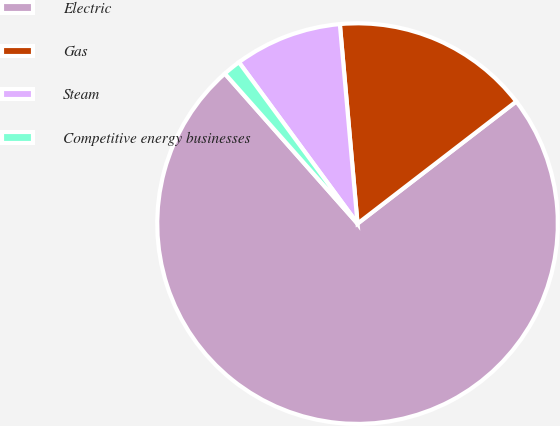<chart> <loc_0><loc_0><loc_500><loc_500><pie_chart><fcel>Electric<fcel>Gas<fcel>Steam<fcel>Competitive energy businesses<nl><fcel>73.91%<fcel>15.97%<fcel>8.68%<fcel>1.44%<nl></chart> 